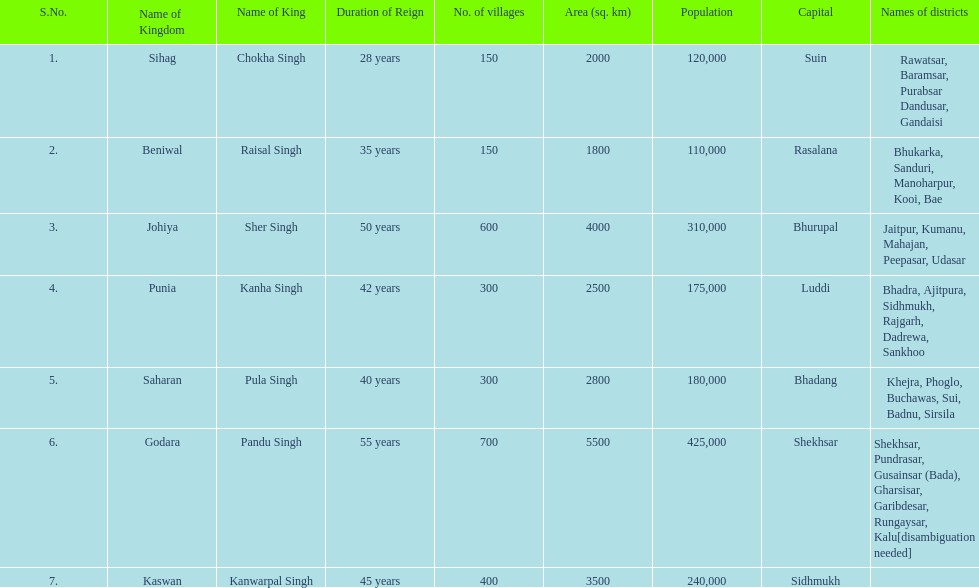Are there more or fewer villages in punia than in godara? Less. 